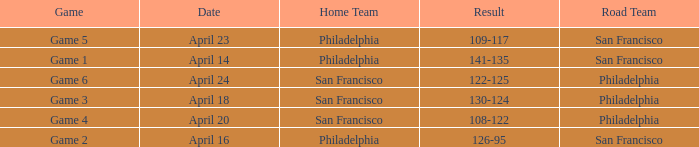What was the result of the game played on April 16 with Philadelphia as home team? 126-95. 